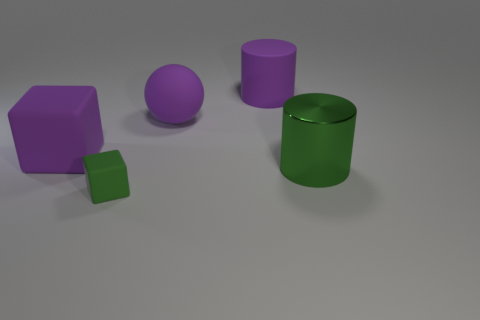Are there any other things that have the same size as the green rubber block?
Offer a very short reply. No. There is a purple matte block; is it the same size as the cylinder in front of the rubber cylinder?
Offer a terse response. Yes. Is the number of big purple things greater than the number of small yellow matte cubes?
Keep it short and to the point. Yes. Is the material of the object left of the green rubber object the same as the green object to the right of the green block?
Your response must be concise. No. What is the material of the big green cylinder?
Your answer should be very brief. Metal. Is the number of large objects that are in front of the small green thing greater than the number of green cylinders?
Ensure brevity in your answer.  No. There is a purple matte block to the left of the green thing that is on the left side of the green cylinder; what number of green cubes are to the left of it?
Ensure brevity in your answer.  0. What is the material of the large object that is in front of the matte ball and on the right side of the purple cube?
Give a very brief answer. Metal. What is the color of the big cube?
Keep it short and to the point. Purple. Is the number of big shiny cylinders that are to the left of the green metallic object greater than the number of purple matte balls to the left of the green rubber object?
Ensure brevity in your answer.  No. 